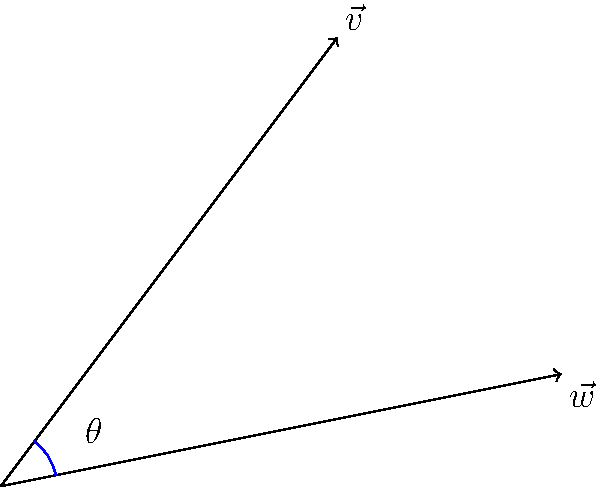In a thrilling scene from "The Incredibles," Dash is running on water while Elastigirl stretches to catch him. Their trajectories can be represented by two vectors: $\vec{v} = 3\hat{i} + 4\hat{j}$ for Dash and $\vec{w} = 5\hat{i} + \hat{j}$ for Elastigirl. What is the angle $\theta$ between these two vectors, representing the convergence of their superpowered movements? To find the angle between two vectors, we can use the dot product formula:

$$\cos \theta = \frac{\vec{v} \cdot \vec{w}}{|\vec{v}||\vec{w}|}$$

Step 1: Calculate the dot product $\vec{v} \cdot \vec{w}$
$$\vec{v} \cdot \vec{w} = (3)(5) + (4)(1) = 15 + 4 = 19$$

Step 2: Calculate the magnitudes of $\vec{v}$ and $\vec{w}$
$$|\vec{v}| = \sqrt{3^2 + 4^2} = \sqrt{9 + 16} = \sqrt{25} = 5$$
$$|\vec{w}| = \sqrt{5^2 + 1^2} = \sqrt{25 + 1} = \sqrt{26}$$

Step 3: Substitute into the formula
$$\cos \theta = \frac{19}{5\sqrt{26}}$$

Step 4: Take the inverse cosine (arccos) of both sides
$$\theta = \arccos(\frac{19}{5\sqrt{26}})$$

Step 5: Calculate the result (approximately)
$$\theta \approx 0.3398 \text{ radians} \approx 19.47°$$

This angle represents the dynamic convergence of Dash and Elastigirl's superpowered movements, showcasing the precise choreography typical of Brad Bird's action sequences, while also symbolizing the individual pursuit of excellence championed in Ayn Rand's philosophy.
Answer: $\theta = \arccos(\frac{19}{5\sqrt{26}}) \approx 19.47°$ 